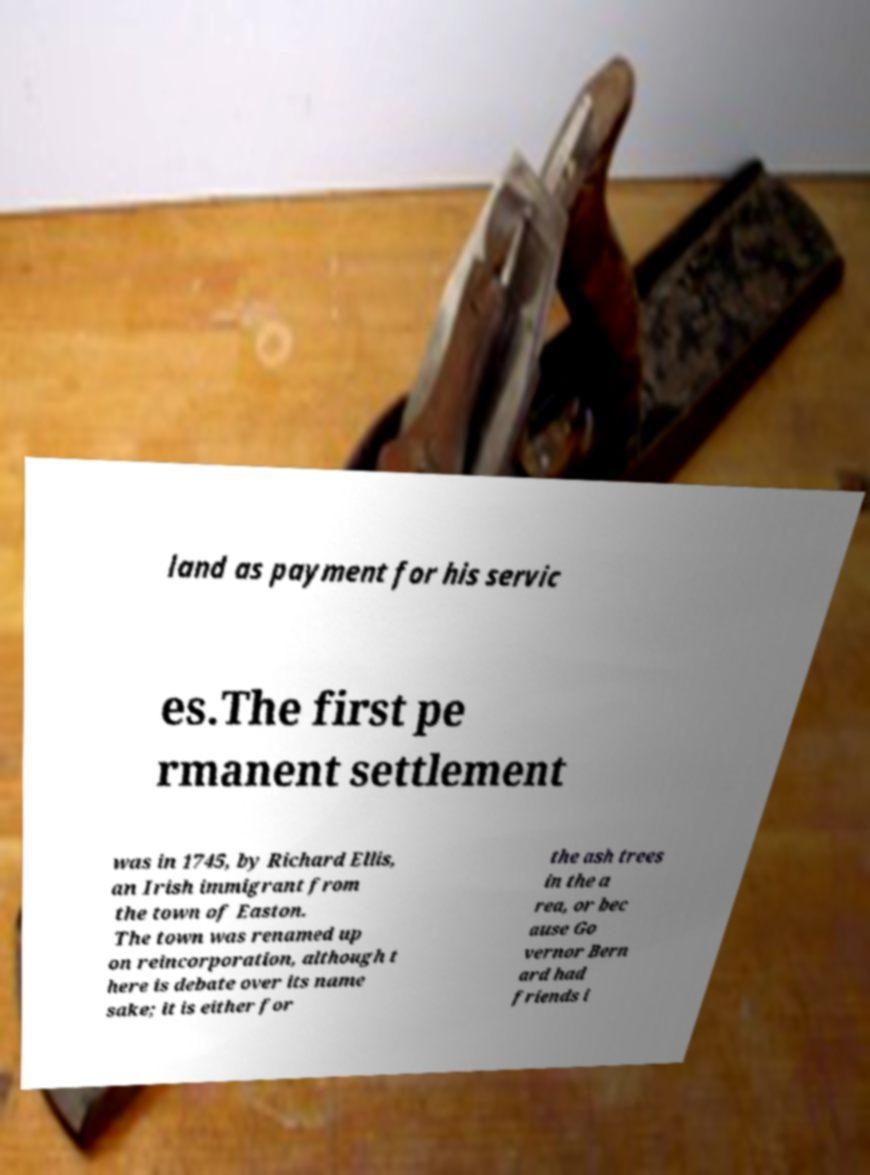Could you extract and type out the text from this image? land as payment for his servic es.The first pe rmanent settlement was in 1745, by Richard Ellis, an Irish immigrant from the town of Easton. The town was renamed up on reincorporation, although t here is debate over its name sake; it is either for the ash trees in the a rea, or bec ause Go vernor Bern ard had friends i 